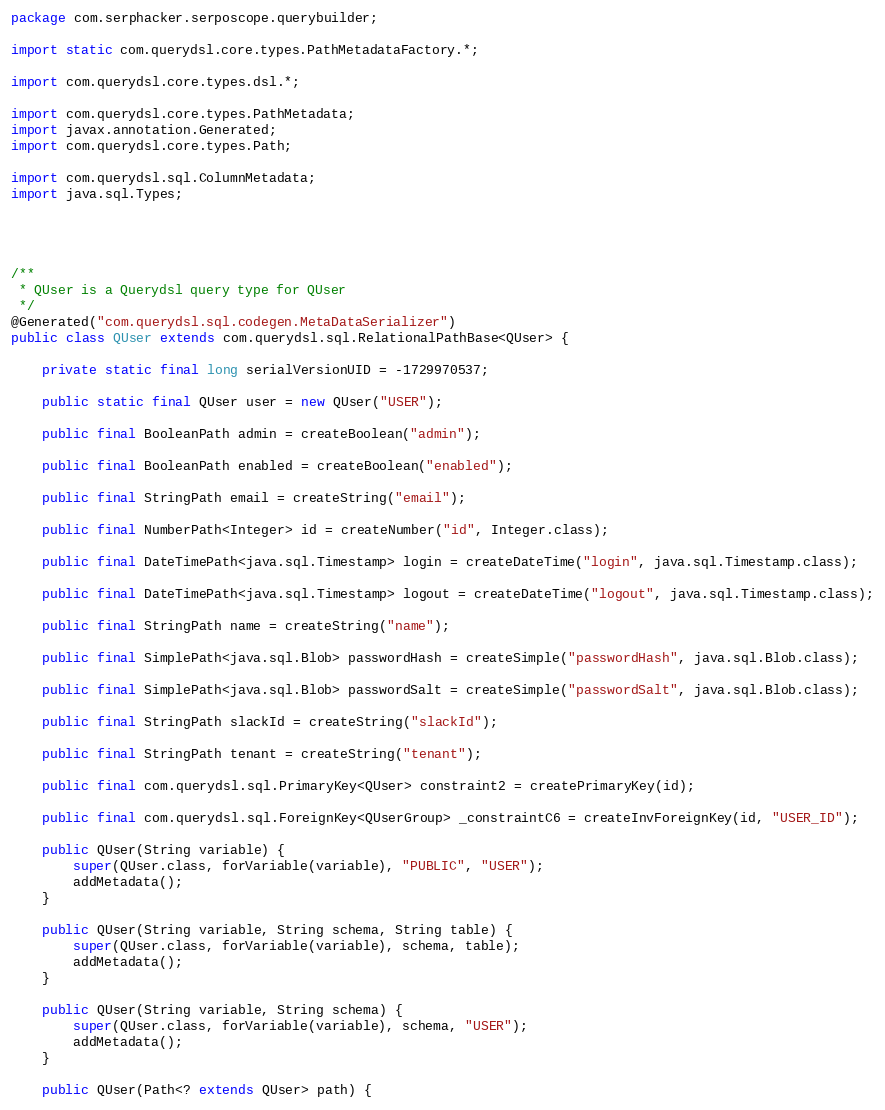Convert code to text. <code><loc_0><loc_0><loc_500><loc_500><_Java_>package com.serphacker.serposcope.querybuilder;

import static com.querydsl.core.types.PathMetadataFactory.*;

import com.querydsl.core.types.dsl.*;

import com.querydsl.core.types.PathMetadata;
import javax.annotation.Generated;
import com.querydsl.core.types.Path;

import com.querydsl.sql.ColumnMetadata;
import java.sql.Types;




/**
 * QUser is a Querydsl query type for QUser
 */
@Generated("com.querydsl.sql.codegen.MetaDataSerializer")
public class QUser extends com.querydsl.sql.RelationalPathBase<QUser> {

    private static final long serialVersionUID = -1729970537;

    public static final QUser user = new QUser("USER");

    public final BooleanPath admin = createBoolean("admin");

    public final BooleanPath enabled = createBoolean("enabled");

    public final StringPath email = createString("email");

    public final NumberPath<Integer> id = createNumber("id", Integer.class);

    public final DateTimePath<java.sql.Timestamp> login = createDateTime("login", java.sql.Timestamp.class);

    public final DateTimePath<java.sql.Timestamp> logout = createDateTime("logout", java.sql.Timestamp.class);

    public final StringPath name = createString("name");

    public final SimplePath<java.sql.Blob> passwordHash = createSimple("passwordHash", java.sql.Blob.class);

    public final SimplePath<java.sql.Blob> passwordSalt = createSimple("passwordSalt", java.sql.Blob.class);

    public final StringPath slackId = createString("slackId");

    public final StringPath tenant = createString("tenant");

    public final com.querydsl.sql.PrimaryKey<QUser> constraint2 = createPrimaryKey(id);

    public final com.querydsl.sql.ForeignKey<QUserGroup> _constraintC6 = createInvForeignKey(id, "USER_ID");

    public QUser(String variable) {
        super(QUser.class, forVariable(variable), "PUBLIC", "USER");
        addMetadata();
    }

    public QUser(String variable, String schema, String table) {
        super(QUser.class, forVariable(variable), schema, table);
        addMetadata();
    }

    public QUser(String variable, String schema) {
        super(QUser.class, forVariable(variable), schema, "USER");
        addMetadata();
    }

    public QUser(Path<? extends QUser> path) {</code> 